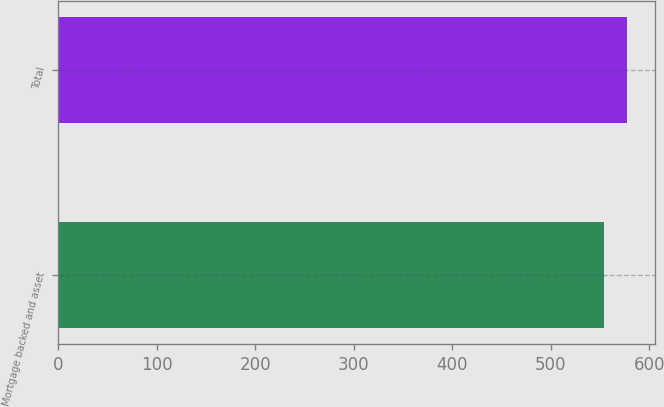<chart> <loc_0><loc_0><loc_500><loc_500><bar_chart><fcel>Mortgage backed and asset<fcel>Total<nl><fcel>554<fcel>577<nl></chart> 